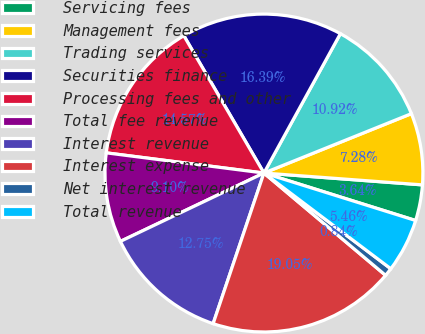Convert chart. <chart><loc_0><loc_0><loc_500><loc_500><pie_chart><fcel>Servicing fees<fcel>Management fees<fcel>Trading services<fcel>Securities finance<fcel>Processing fees and other<fcel>Total fee revenue<fcel>Interest revenue<fcel>Interest expense<fcel>Net interest revenue<fcel>Total revenue<nl><fcel>3.64%<fcel>7.28%<fcel>10.92%<fcel>16.39%<fcel>14.57%<fcel>9.1%<fcel>12.75%<fcel>19.05%<fcel>0.84%<fcel>5.46%<nl></chart> 